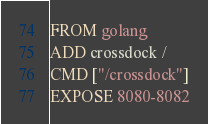<code> <loc_0><loc_0><loc_500><loc_500><_Dockerfile_>FROM golang
ADD crossdock /
CMD ["/crossdock"]
EXPOSE 8080-8082
</code> 